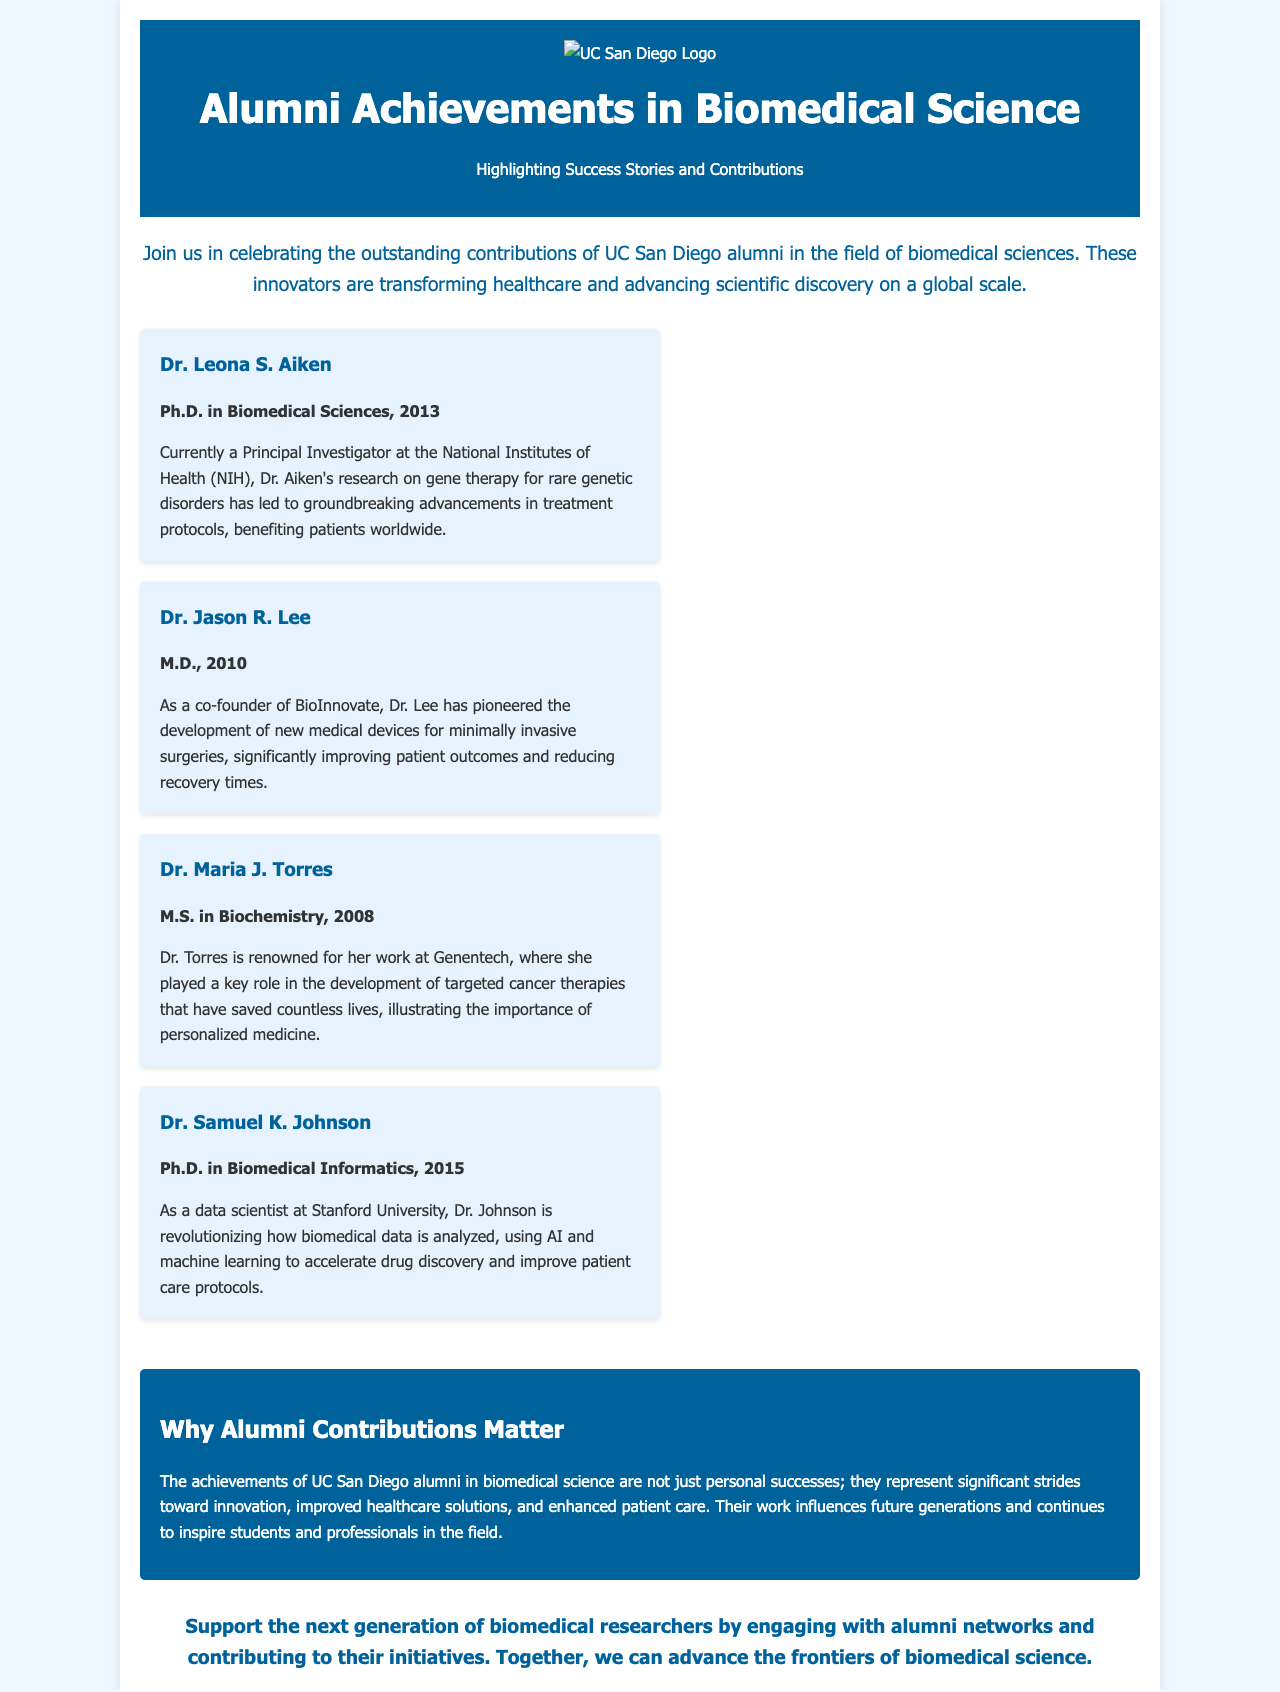what is the title of the brochure? The title of the brochure is prominently displayed in the header section.
Answer: Alumni Achievements in Biomedical Science who is the Principal Investigator at the NIH? Dr. Aiken’s role is highlighted in the first highlight card.
Answer: Dr. Leona S. Aiken what year did Dr. Jason R. Lee graduate? The graduation year is provided in bold text within his highlight card.
Answer: 2010 what organization did Dr. Maria J. Torres work for? The document states her affiliation in her highlight card.
Answer: Genentech what is the main focus of Dr. Samuel K. Johnson's work? The highlight card details the specific area of advancement he is contributing to.
Answer: Biomedical data analysis how do UC San Diego alumni contribute to healthcare solutions? The brochure emphasizes the impact of alumni achievements on the field.
Answer: Significant strides toward innovation what is the color scheme of the document design? The colors used in the background and text provide clues about the design aesthetic.
Answer: Light blue and white what promotional action does the call to action encourage? The call to action section communicates a specific engagement strategy.
Answer: Support the next generation what degree did Dr. Leona S. Aiken earn? The educational background of Dr. Aiken is mentioned in her highlight card.
Answer: Ph.D. in Biomedical Sciences how many highlights are listed in the brochure? The number of highlight cards indicates the number of featured alumni in the document.
Answer: Four 